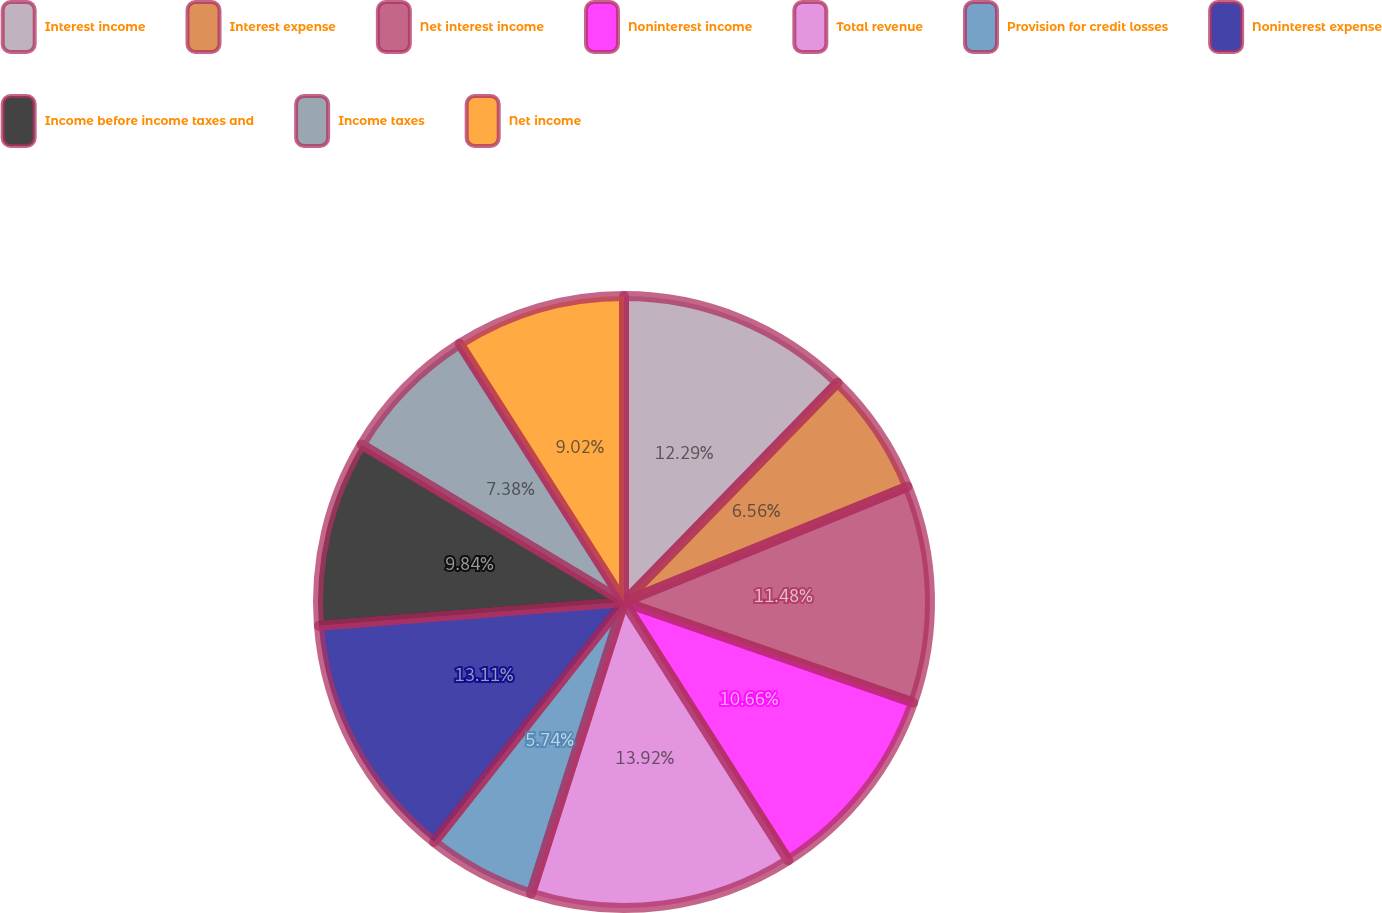<chart> <loc_0><loc_0><loc_500><loc_500><pie_chart><fcel>Interest income<fcel>Interest expense<fcel>Net interest income<fcel>Noninterest income<fcel>Total revenue<fcel>Provision for credit losses<fcel>Noninterest expense<fcel>Income before income taxes and<fcel>Income taxes<fcel>Net income<nl><fcel>12.29%<fcel>6.56%<fcel>11.48%<fcel>10.66%<fcel>13.93%<fcel>5.74%<fcel>13.11%<fcel>9.84%<fcel>7.38%<fcel>9.02%<nl></chart> 